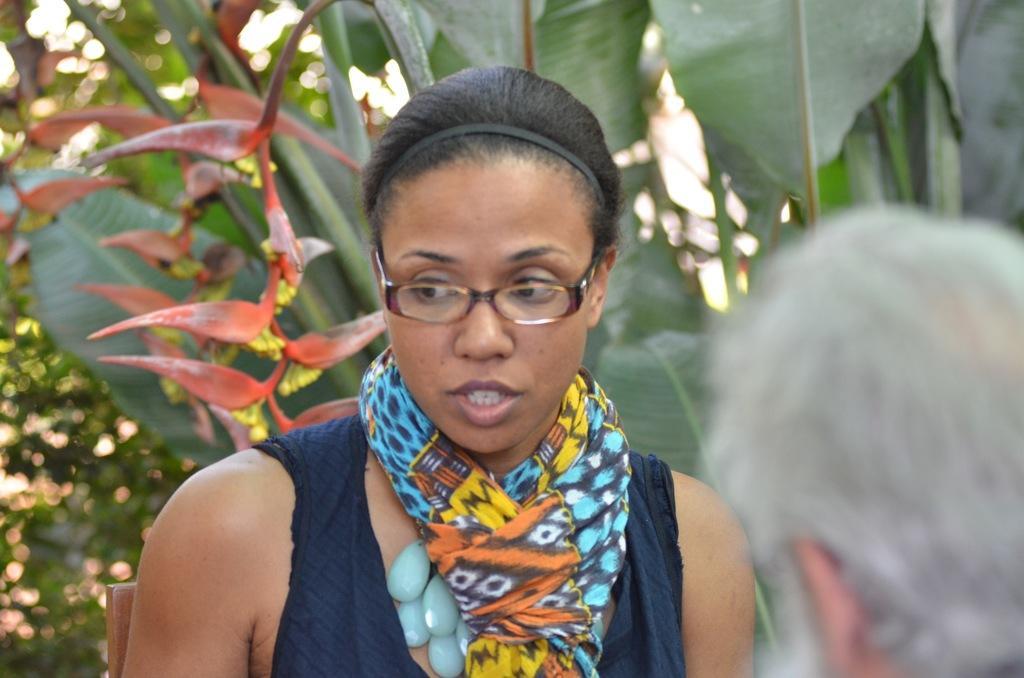Please provide a concise description of this image. In the image we can see there is a woman and a person standing. Behind there are plants and trees. Background of the image is little blurred. 